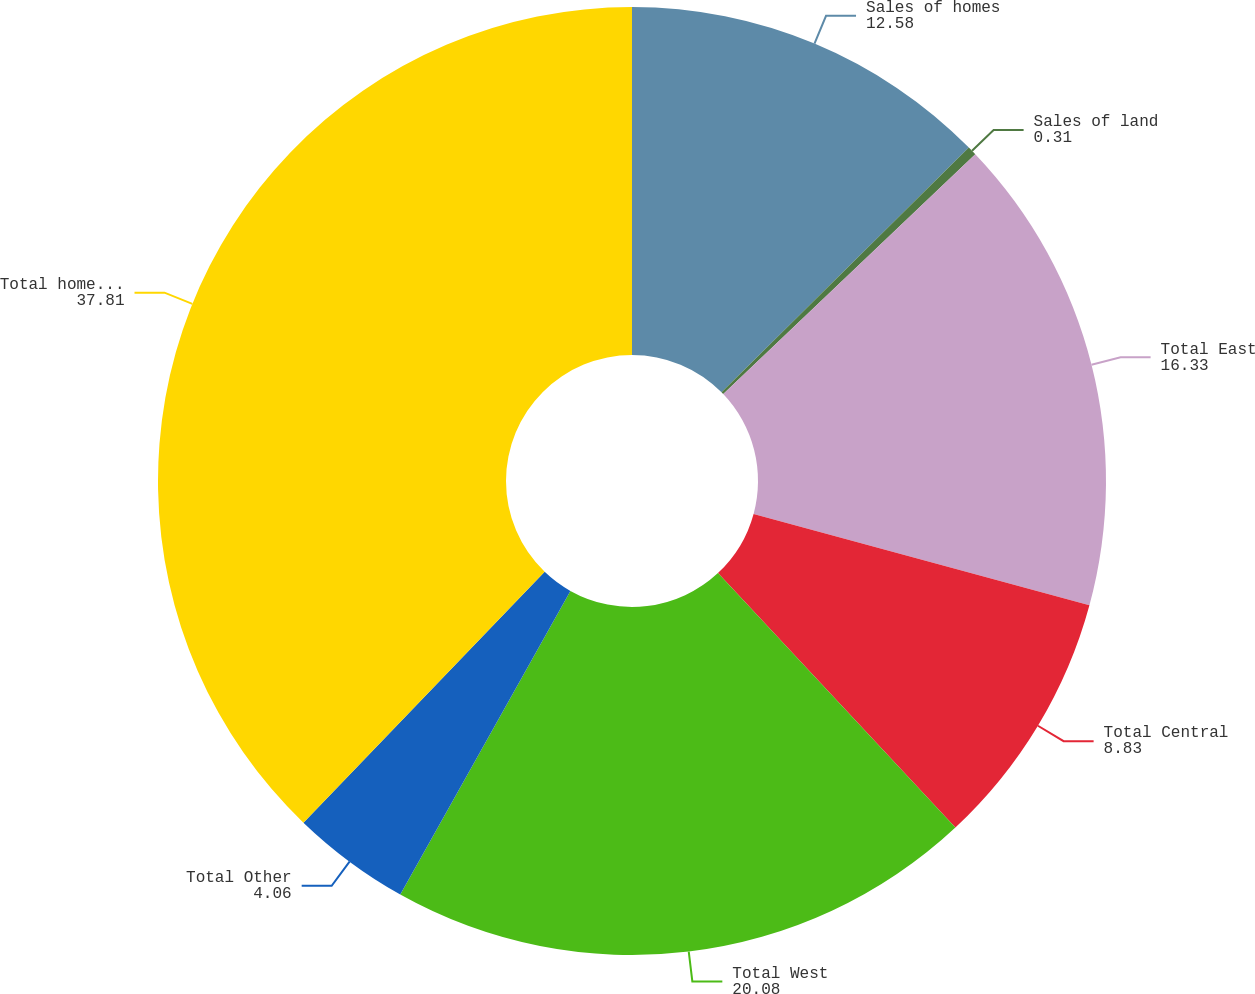<chart> <loc_0><loc_0><loc_500><loc_500><pie_chart><fcel>Sales of homes<fcel>Sales of land<fcel>Total East<fcel>Total Central<fcel>Total West<fcel>Total Other<fcel>Total homebuilding revenues<nl><fcel>12.58%<fcel>0.31%<fcel>16.33%<fcel>8.83%<fcel>20.08%<fcel>4.06%<fcel>37.81%<nl></chart> 